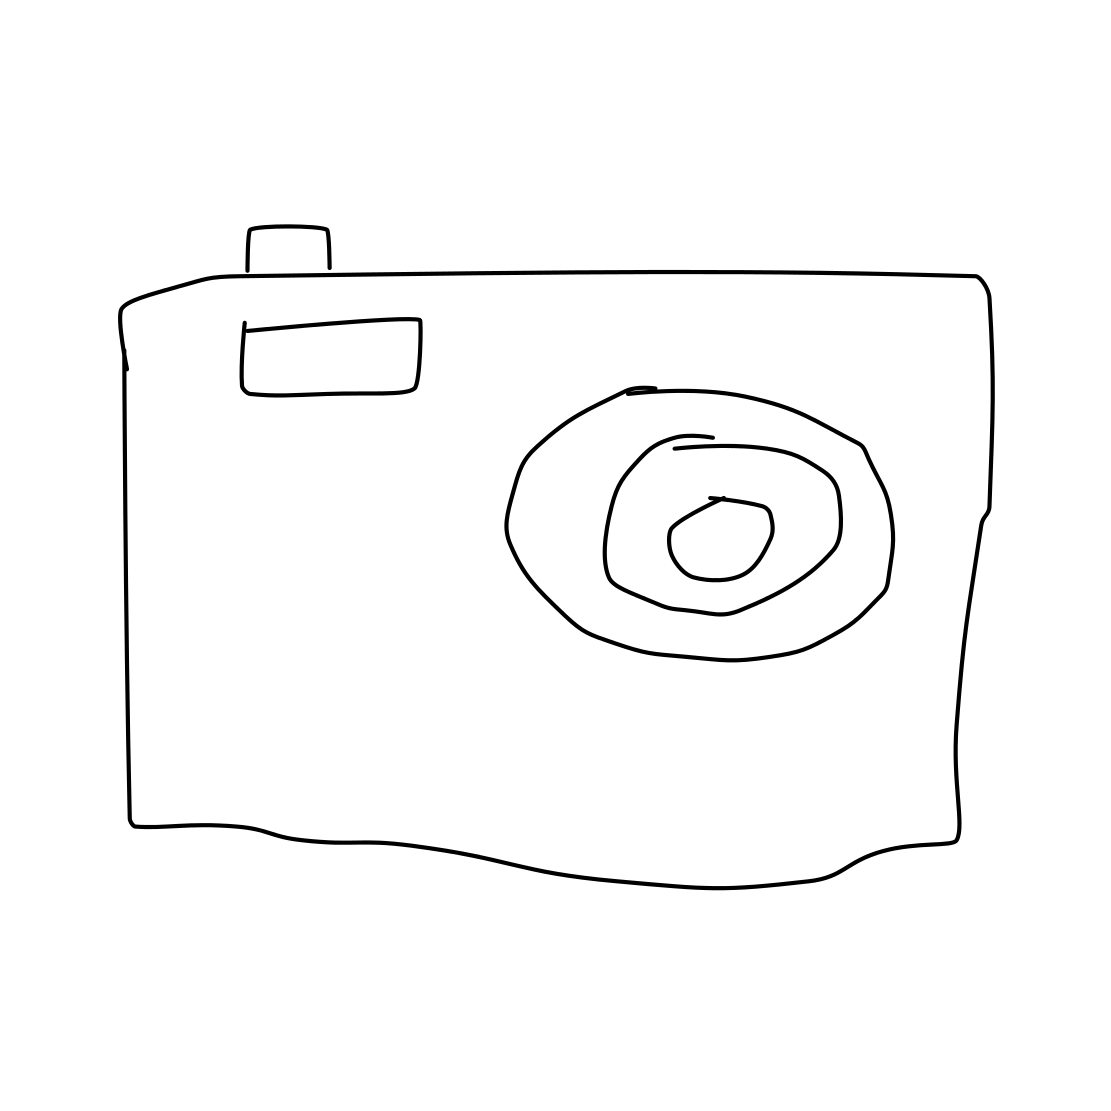In the scene, is a hedgehog in it? No 